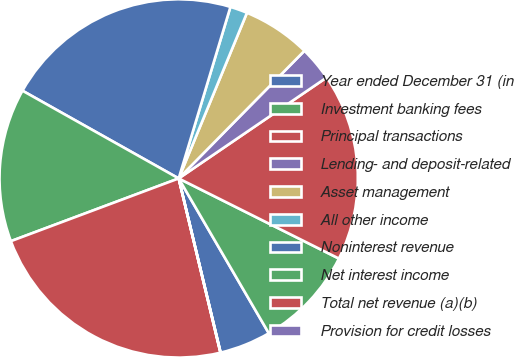Convert chart. <chart><loc_0><loc_0><loc_500><loc_500><pie_chart><fcel>Year ended December 31 (in<fcel>Investment banking fees<fcel>Principal transactions<fcel>Lending- and deposit-related<fcel>Asset management<fcel>All other income<fcel>Noninterest revenue<fcel>Net interest income<fcel>Total net revenue (a)(b)<fcel>Provision for credit losses<nl><fcel>4.63%<fcel>9.23%<fcel>16.91%<fcel>3.09%<fcel>6.16%<fcel>1.56%<fcel>21.52%<fcel>13.84%<fcel>23.05%<fcel>0.02%<nl></chart> 